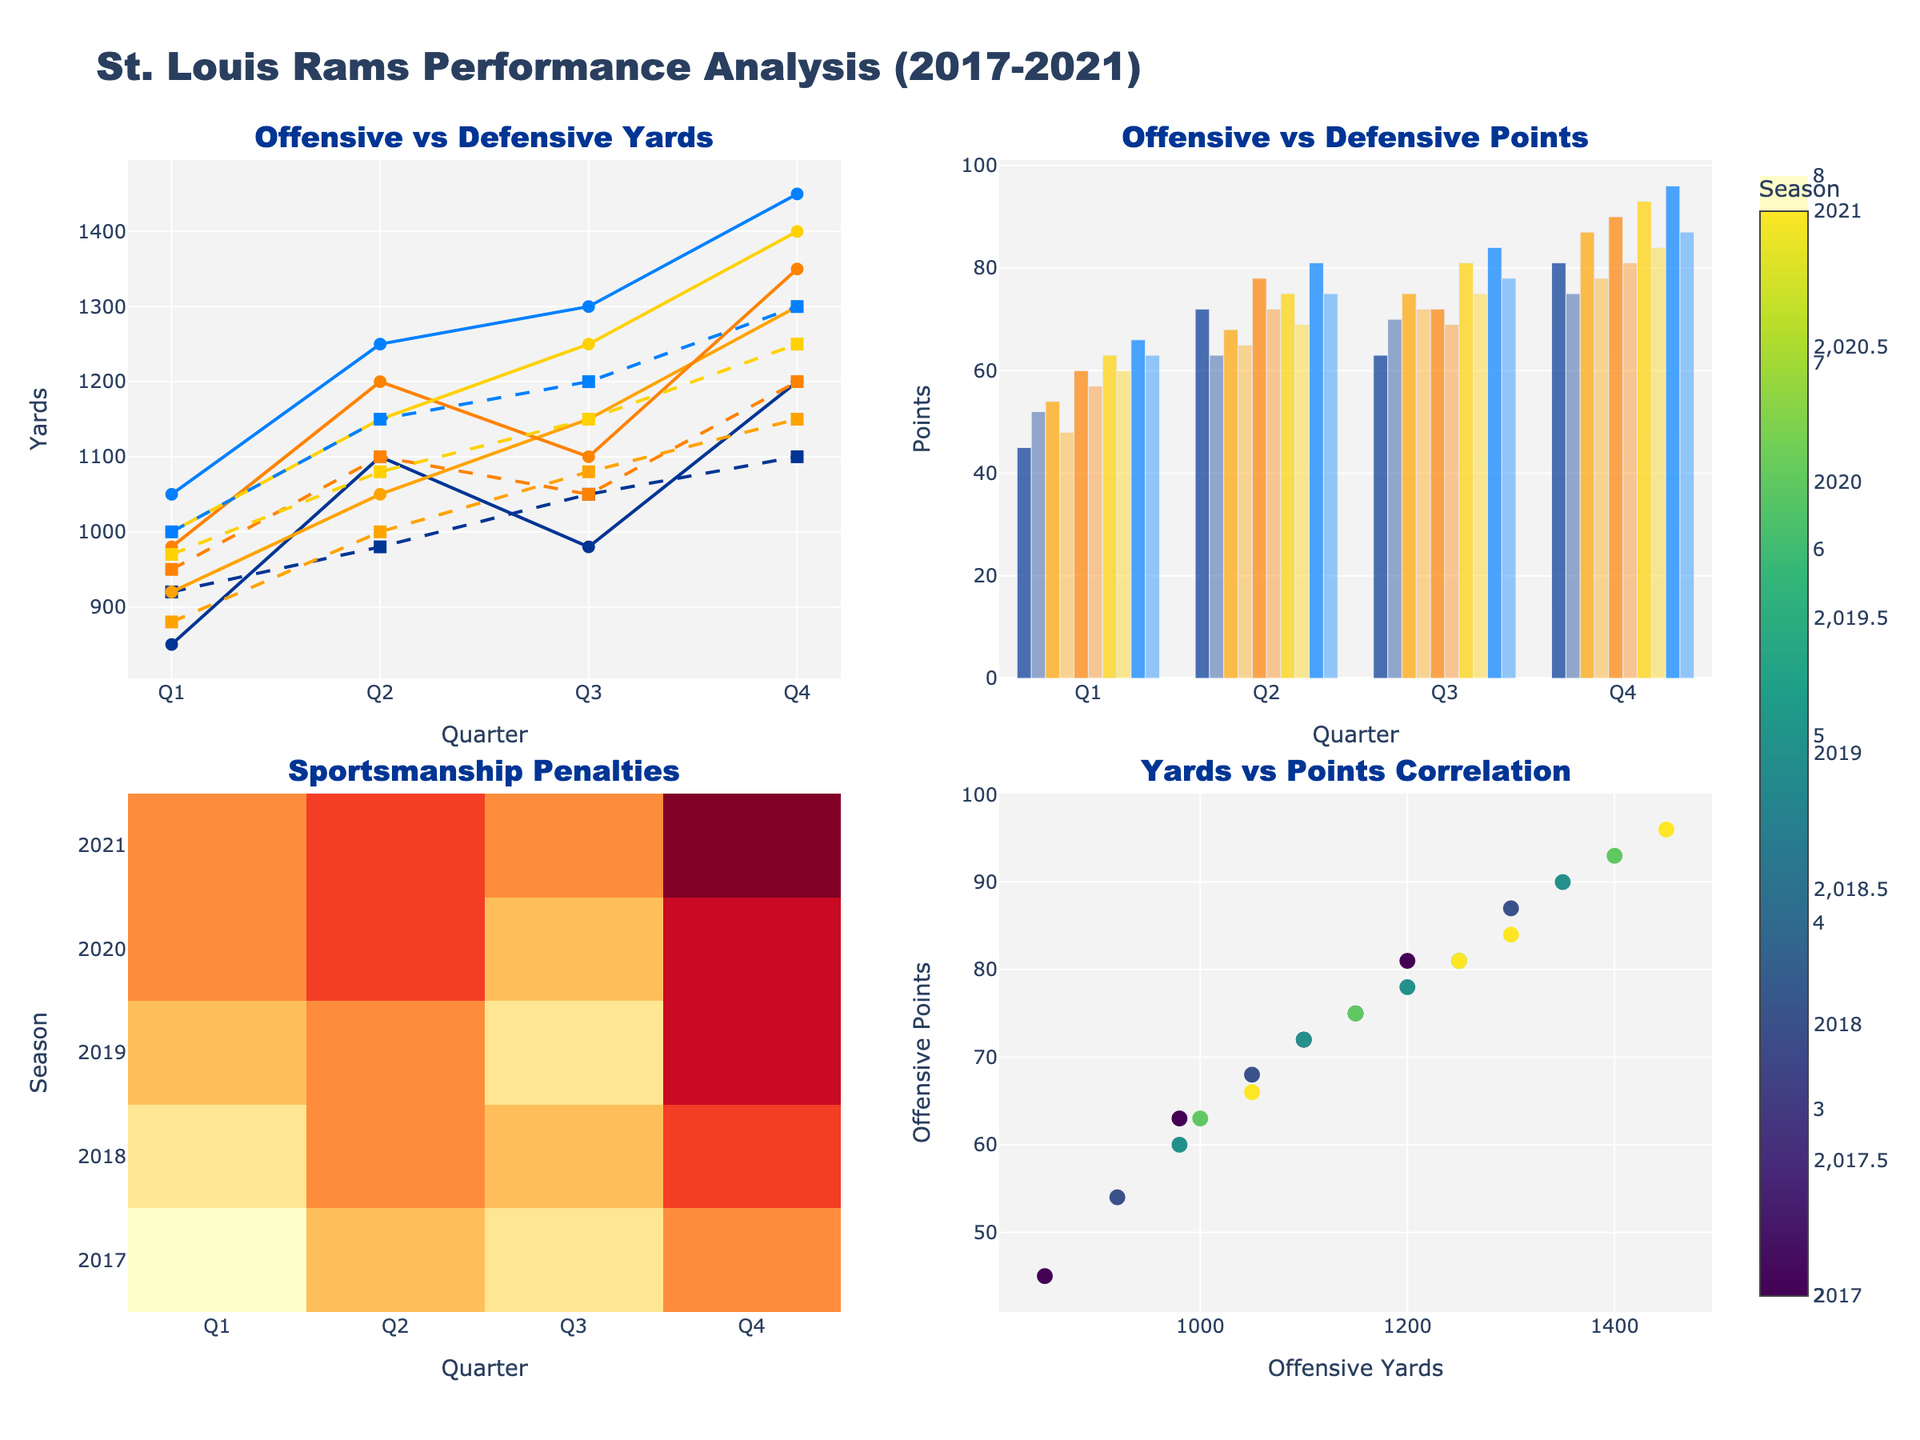What is the title of the overall figure? The title of the figure is displayed at the top and reads, "St. Louis Rams Performance Analysis (2017-2021)."
Answer: St. Louis Rams Performance Analysis (2017-2021) How many quarters are there in each subplot? Each subplot has 4 quarters labeled as Q1, Q2, Q3, and Q4 on the x-axis.
Answer: 4 Which season shows the highest number of sportsmanship penalties in the first quarter? In the sportsmanship penalties heatmap (bottom left subplot), the 2017 season has the highest value (8) in the first quarter (Q1).
Answer: 2017 What is the offensive yard difference between Q1 and Q4 in the 2021 season? For the 2021 season, the offensive yards in Q1 are 1050, and in Q4 they are 1450. The difference is 1450 - 1050.
Answer: 400 In which quarter do the St. Louis Rams have the highest offensive points across all seasons? In the top-right bar chart, Q4 of the 2021 season shows the maximum offensive points of 96.
Answer: Q4, 2021 Compare the defensive points allowed in Q3 of 2019 and Q3 of 2021. Which quarter has more defensive points allowed, and what is the difference? In the top-right subplot, Q3 of 2019 has 69 defensive points allowed, and Q3 of 2021 has 78 defensive points allowed. Thus, Q3 of 2021 has more by 78 - 69 points.
Answer: Q3, 2021; 9 points Which color is used to represent the 2019 season in the figure? The 2019 season is represented using the second color listed, which is '#FFA300'. This can be seen in the legends.
Answer: #FFA300 What is the correlation between offensive yards and offensive points? In the bottom-right scatter plot, as offensive yards increase, the offensive points tend to increase as well, indicating a positive correlation.
Answer: Positive correlation What is the average number of sportsmanship penalties per quarter across all seasons? Add up all the sportsmanship penalties for each quarter and divide by the total number of quarters (5 seasons * 4 quarters = 20). The sum is 8+7+6+5+7+5+6+4+6+5+7+3+5+4+6+3+5+4+5+2 = 98. The average is 98/20.
Answer: 4.9 Which quarter has the lowest offensive points in 2018, and how many points? In the top-right subplot, Q1 of 2018 has the lowest offensive points with a value of 54.
Answer: Q1, 54 